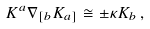Convert formula to latex. <formula><loc_0><loc_0><loc_500><loc_500>K ^ { a } \nabla _ { [ b } K _ { a ] } \cong \pm \kappa K _ { b } \, ,</formula> 